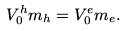Convert formula to latex. <formula><loc_0><loc_0><loc_500><loc_500>V _ { 0 } ^ { h } m _ { h } = V _ { 0 } ^ { e } m _ { e } .</formula> 